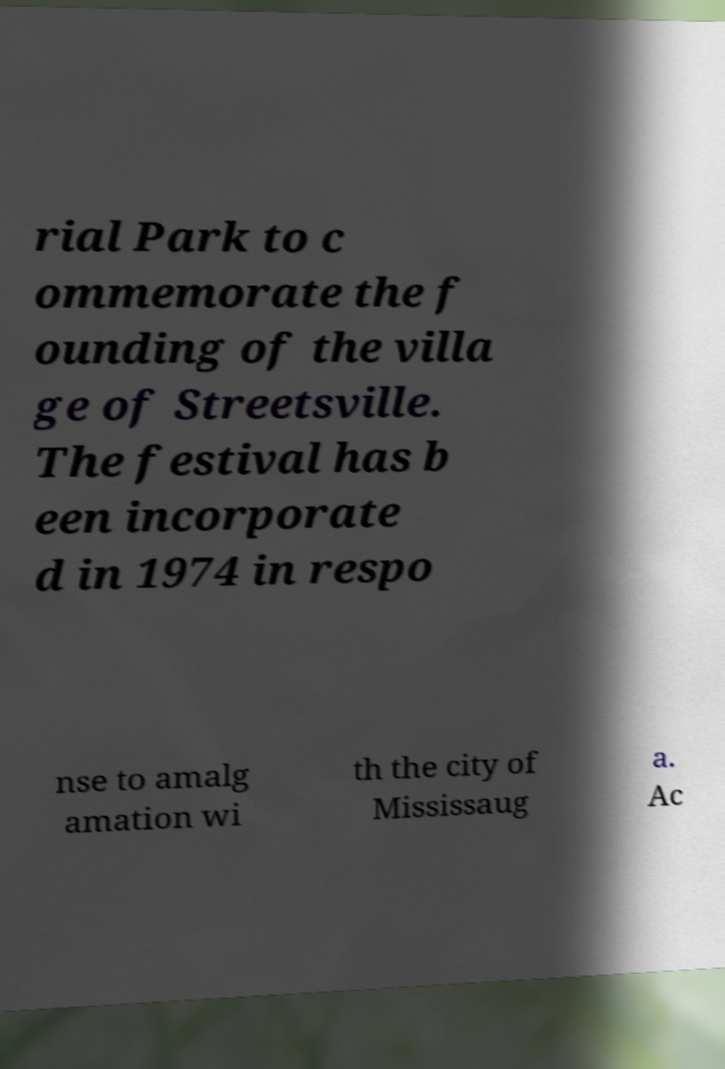Can you read and provide the text displayed in the image?This photo seems to have some interesting text. Can you extract and type it out for me? rial Park to c ommemorate the f ounding of the villa ge of Streetsville. The festival has b een incorporate d in 1974 in respo nse to amalg amation wi th the city of Mississaug a. Ac 